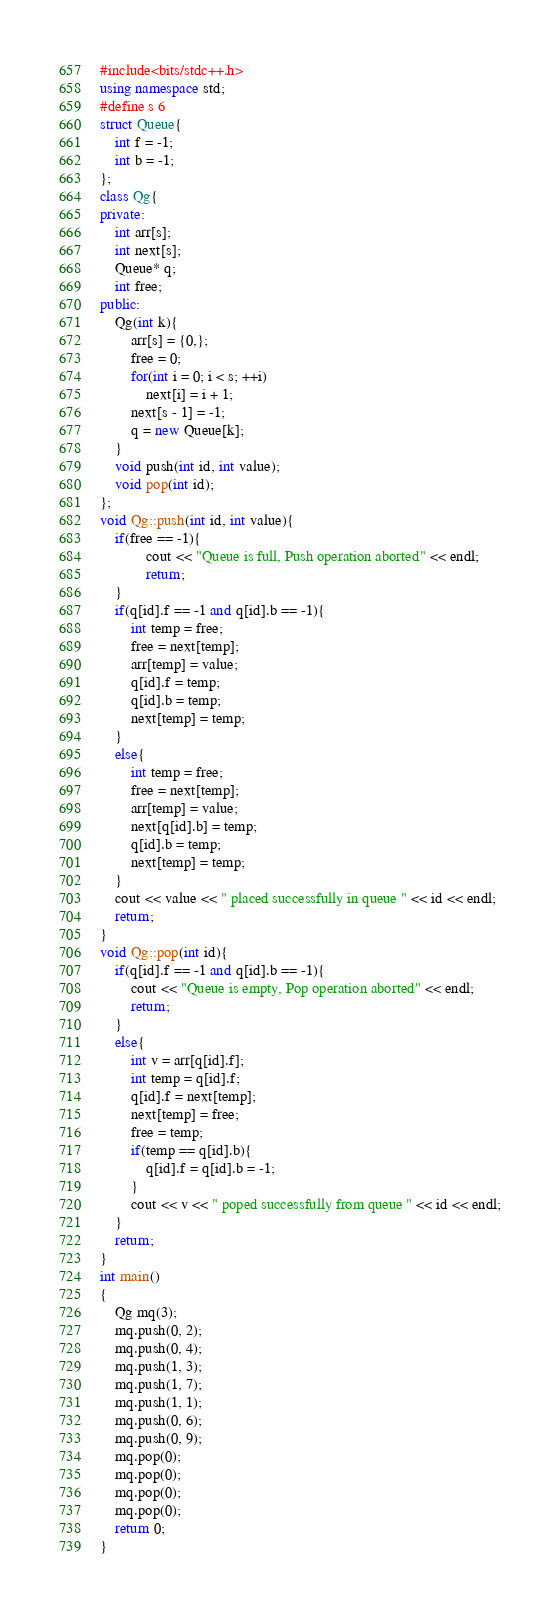Convert code to text. <code><loc_0><loc_0><loc_500><loc_500><_C++_>#include<bits/stdc++.h>
using namespace std;
#define s 6
struct Queue{
    int f = -1;
    int b = -1;
};
class Qg{
private:
    int arr[s];
    int next[s];
    Queue* q;
    int free;
public:
    Qg(int k){
        arr[s] = {0,};
        free = 0;
        for(int i = 0; i < s; ++i)
            next[i] = i + 1;
        next[s - 1] = -1;
        q = new Queue[k];
    }
    void push(int id, int value);
    void pop(int id);
};
void Qg::push(int id, int value){
    if(free == -1){
            cout << "Queue is full, Push operation aborted" << endl;
            return;
    }
    if(q[id].f == -1 and q[id].b == -1){
        int temp = free;
        free = next[temp];
        arr[temp] = value;
        q[id].f = temp;
        q[id].b = temp;
        next[temp] = temp;
    }
    else{
        int temp = free;
        free = next[temp];
        arr[temp] = value;
        next[q[id].b] = temp;
        q[id].b = temp;
        next[temp] = temp;
    }
    cout << value << " placed successfully in queue " << id << endl;
    return;
}
void Qg::pop(int id){
    if(q[id].f == -1 and q[id].b == -1){
        cout << "Queue is empty, Pop operation aborted" << endl;
        return;
    }
    else{
        int v = arr[q[id].f];
        int temp = q[id].f;
        q[id].f = next[temp];
        next[temp] = free;
        free = temp;
        if(temp == q[id].b){
            q[id].f = q[id].b = -1;
        }
        cout << v << " poped successfully from queue " << id << endl;
    }
    return;
}
int main()
{
    Qg mq(3);
    mq.push(0, 2);
    mq.push(0, 4);
    mq.push(1, 3);
    mq.push(1, 7);
    mq.push(1, 1);
    mq.push(0, 6);
    mq.push(0, 9);
    mq.pop(0);
    mq.pop(0);
    mq.pop(0);
    mq.pop(0);
    return 0;
}

</code> 